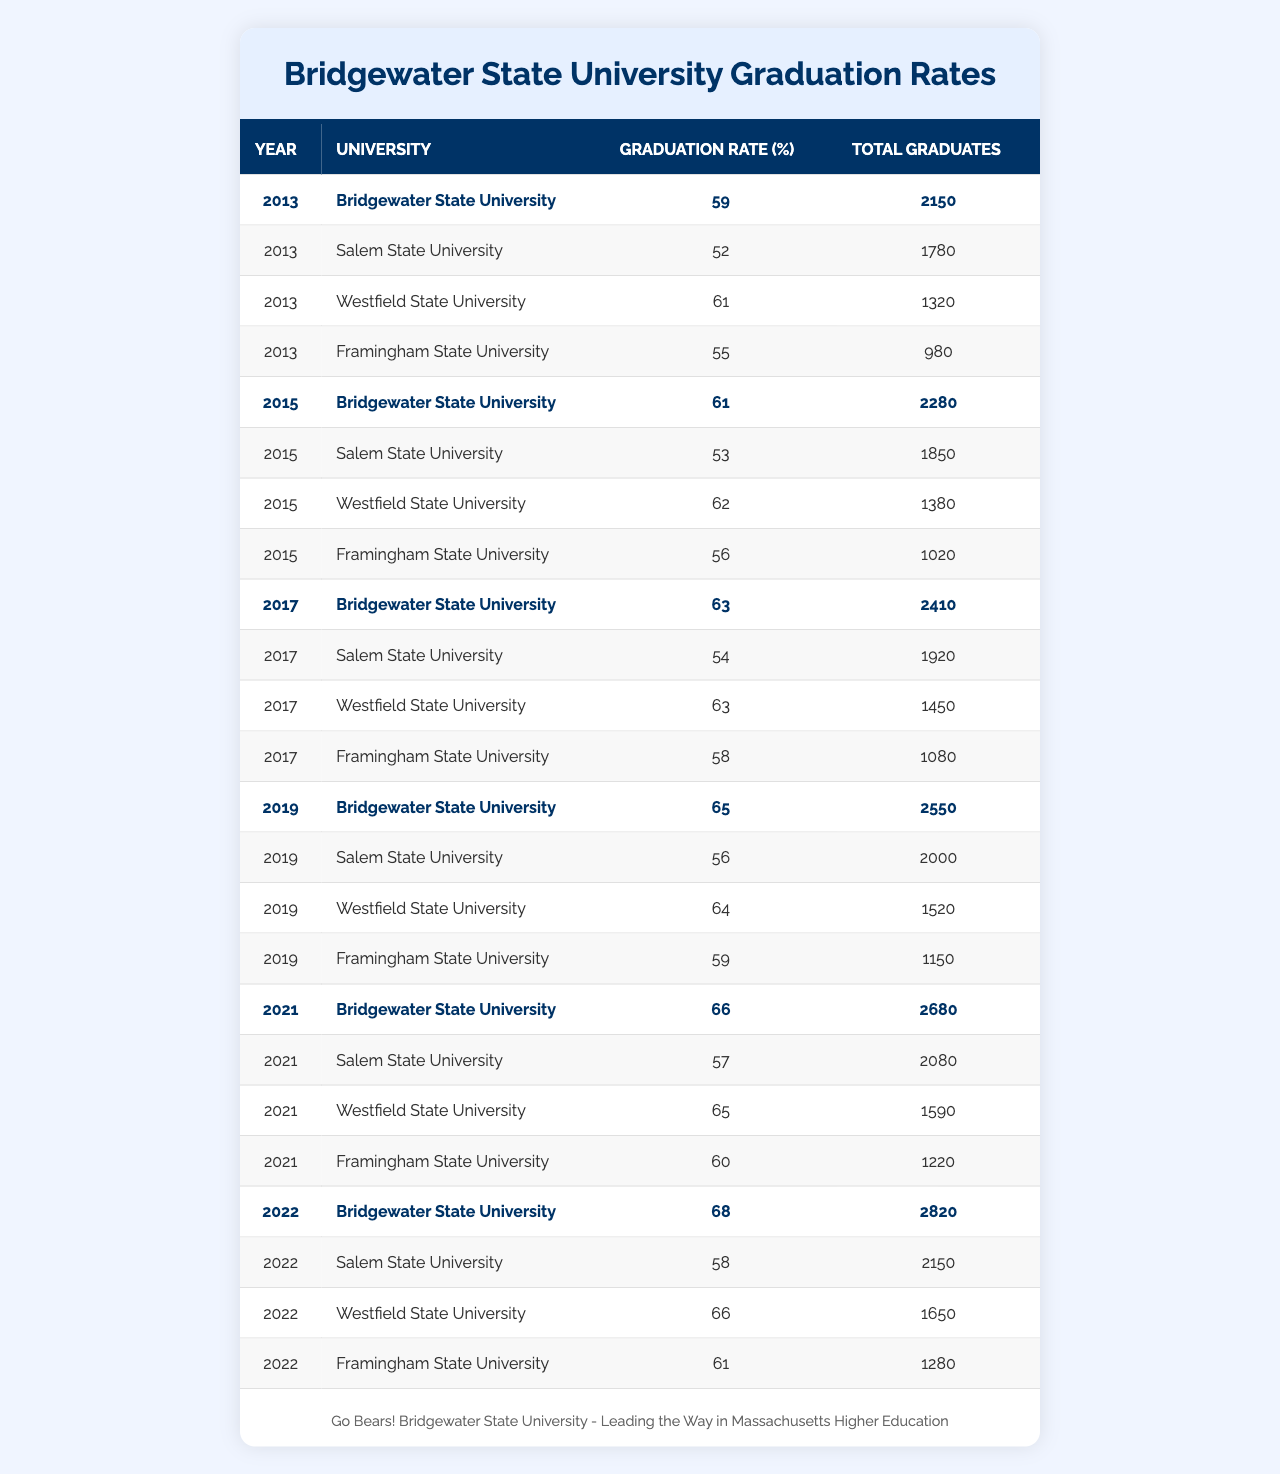What was the graduation rate for Bridgewater State University in 2021? Looking at the table, the row for Bridgewater State University in 2021 indicates a graduation rate of 66%.
Answer: 66% Which university had the lowest graduation rate in 2013? In the 2013 data, Salem State University has the lowest graduation rate at 52%.
Answer: Salem State University What is the average graduation rate for all universities in 2019? Adding the graduation rates for 2019: (65 + 56 + 64 + 59) = 244. There are 4 universities, so the average is 244/4 = 61%.
Answer: 61% Did Bridgewater State University show consistent improvement in graduation rates from 2013 to 2022? By comparing the graduation rates for Bridgewater State University from 2013 (59%) to 2022 (68%), we can see an increase each year, confirming consistent improvement.
Answer: Yes In which year did Framingham State University achieve a graduation rate of 61%? The table shows that Framingham State University reached a graduation rate of 61% in 2022.
Answer: 2022 Which university had a total of 2680 graduates in 2021? The table indicates that the total number of graduates for Bridgewater State University in 2021 was 2680.
Answer: Bridgewater State University How does the graduation rate of Westfield State University compare to that of Bridgewater State University in 2017? In 2017, Westfield State University had a graduation rate of 63%, which is the same as Bridgewater State University's rate of 63%, indicating they were equal that year.
Answer: They are equal What was the increase in graduation rate for Bridgewater State University from 2015 to 2021? The graduation rate for Bridgewater State University rose from 61% in 2015 to 66% in 2021, so the increase is 66% - 61% = 5%.
Answer: 5% Which university had the highest total graduates in 2022, and what was their graduation rate? The table shows that Bridgewater State University had the highest total of 2820 graduates in 2022, with a graduation rate of 68%.
Answer: Bridgewater State University, 68% If we look at the data over the decade, what is the trend in graduation rates for Salem State University? Looking across the years, Salem State University's graduation rates show a gradual increase from 52% in 2013 to 58% in 2022, indicating a positive trend overall.
Answer: Positive trend 